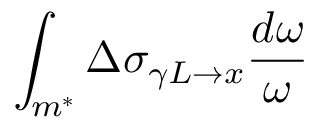Convert formula to latex. <formula><loc_0><loc_0><loc_500><loc_500>\int _ { m ^ { * } } \Delta \sigma _ { \gamma L \rightarrow x } \frac { d \omega } { \omega }</formula> 